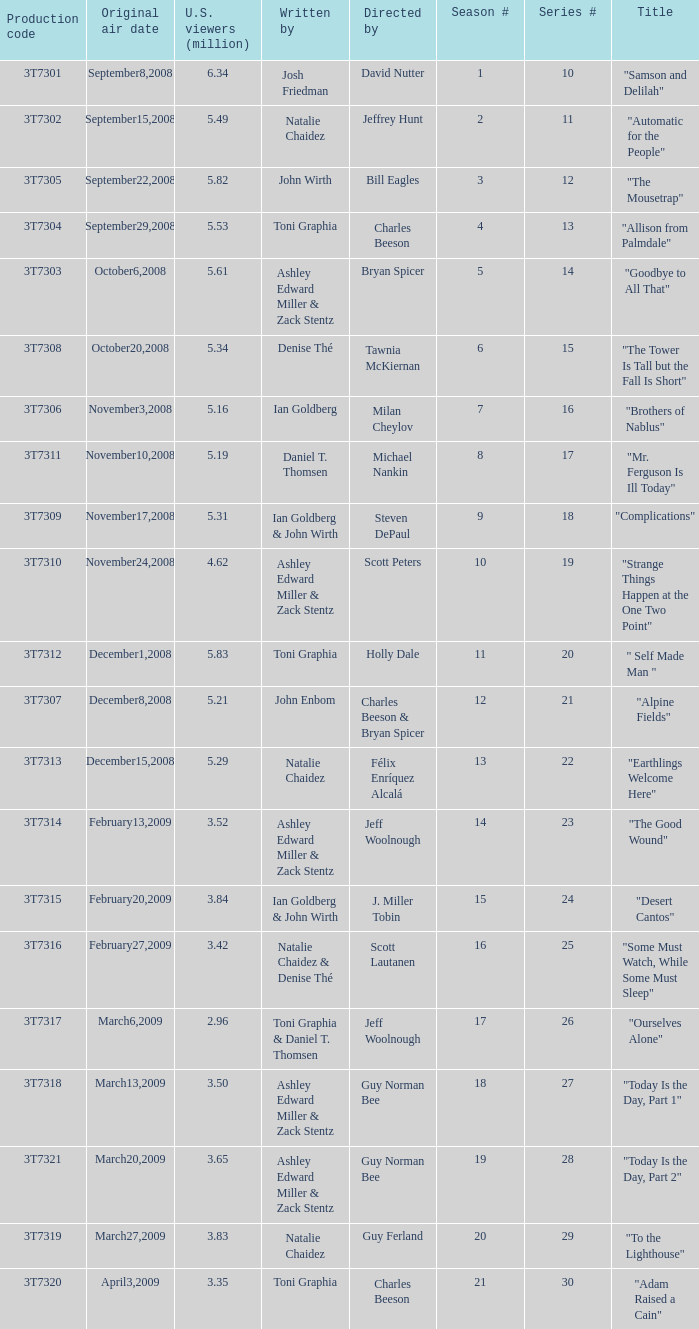Which episode number drew in 3.84 million viewers in the U.S.? 24.0. 